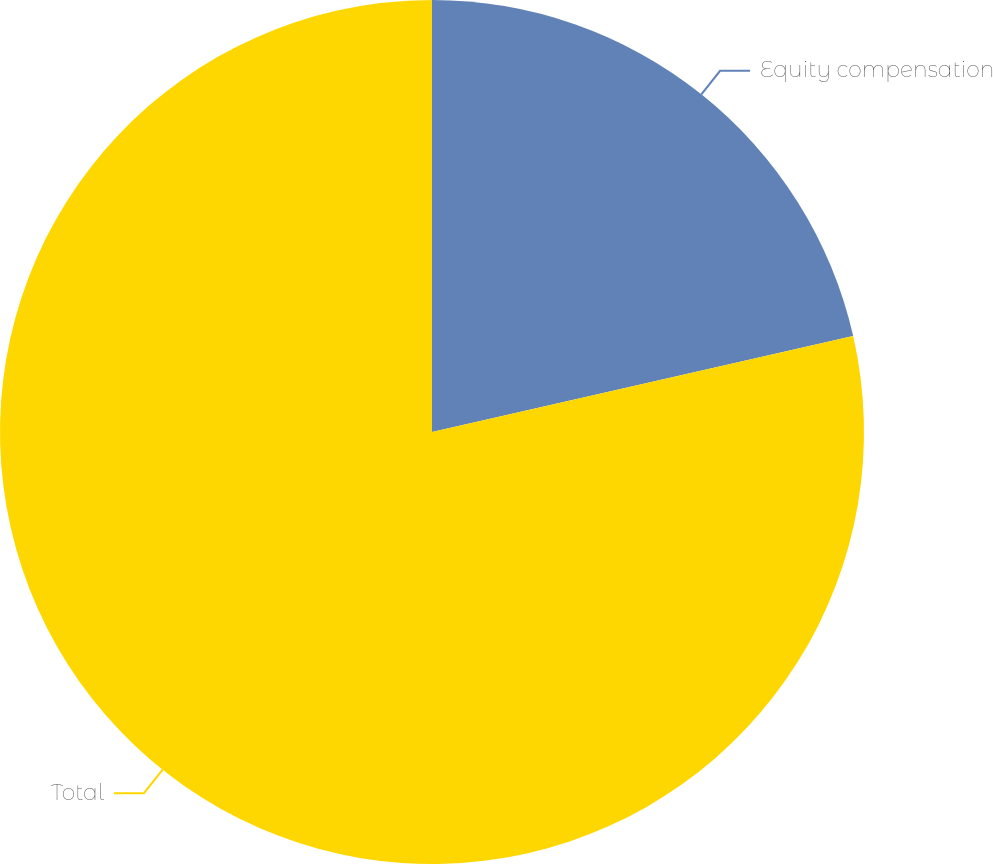Convert chart. <chart><loc_0><loc_0><loc_500><loc_500><pie_chart><fcel>Equity compensation<fcel>Total<nl><fcel>21.43%<fcel>78.57%<nl></chart> 